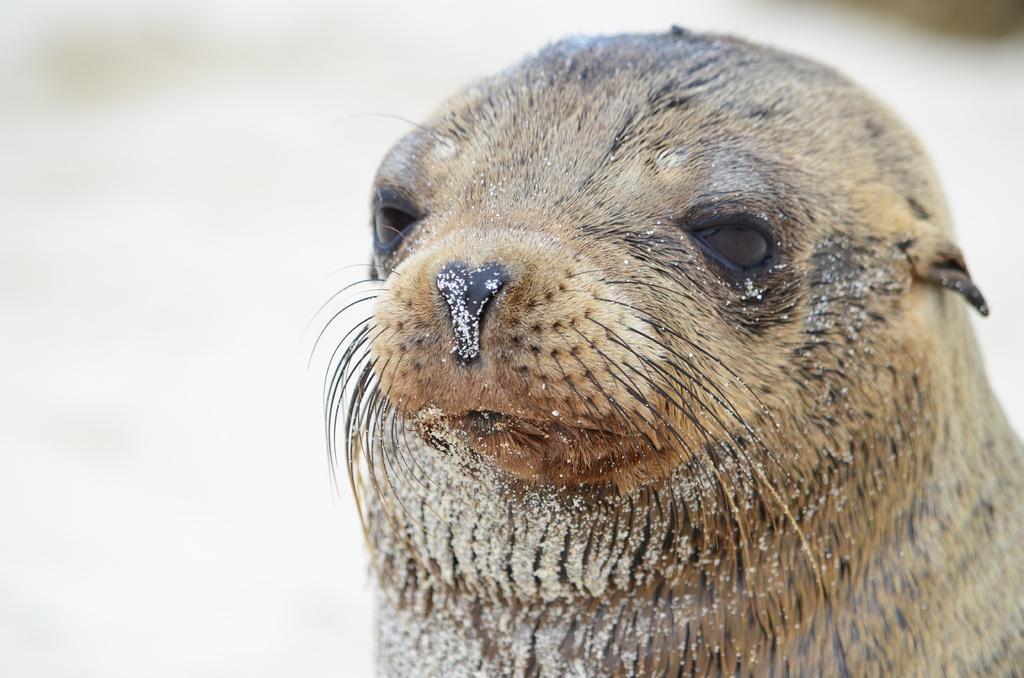How would you summarize this image in a sentence or two? In the foreground of the image there is a animal. The background of the image is blur. 